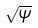<formula> <loc_0><loc_0><loc_500><loc_500>\sqrt { \psi }</formula> 